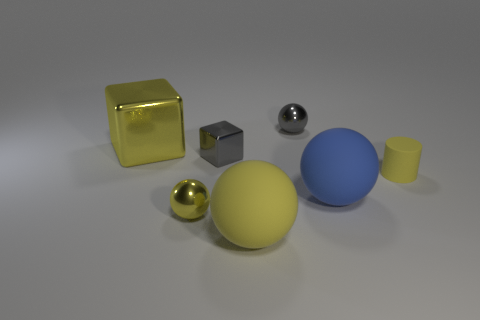There is a small cube that is made of the same material as the big yellow block; what color is it?
Ensure brevity in your answer.  Gray. Do the big blue thing and the tiny metallic thing behind the big yellow metallic cube have the same shape?
Offer a very short reply. Yes. There is a large sphere that is the same color as the tiny matte cylinder; what material is it?
Your answer should be compact. Rubber. There is a gray sphere that is the same size as the yellow matte cylinder; what is its material?
Ensure brevity in your answer.  Metal. Is there a big matte ball that has the same color as the large metal object?
Your response must be concise. Yes. The thing that is both in front of the blue thing and on the left side of the large yellow matte object has what shape?
Keep it short and to the point. Sphere. How many large objects are made of the same material as the blue ball?
Provide a short and direct response. 1. Is the number of tiny gray cubes that are in front of the gray shiny block less than the number of tiny yellow objects to the left of the big blue ball?
Provide a short and direct response. Yes. There is a tiny gray thing in front of the tiny ball that is to the right of the big yellow object to the right of the tiny shiny block; what is its material?
Give a very brief answer. Metal. How big is the yellow object that is on the left side of the tiny yellow cylinder and to the right of the yellow shiny sphere?
Offer a terse response. Large. 